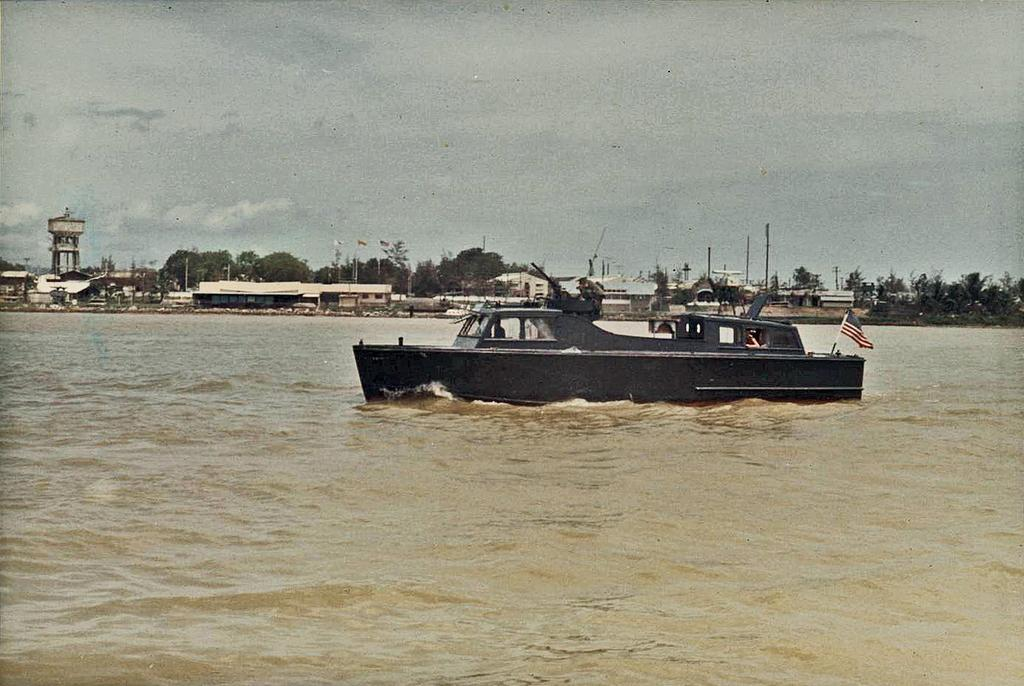What is the main subject of the image? The main subject of the image is a ship on a lake. What can be seen on the land behind the ship? There are buildings on the land behind the ship. What type of vegetation is present on either side of the land? There are many trees on either side of the land. What is located on the left side of the land? There is a tanker on the left side of the land. What is visible in the sky in the image? The sky is visible in the image, and clouds are present. Are there any dolls visible in the image? No, there are no dolls present in the image. Can you see any writing on the ship or buildings in the image? No, there is no visible writing on the ship or buildings in the image. 